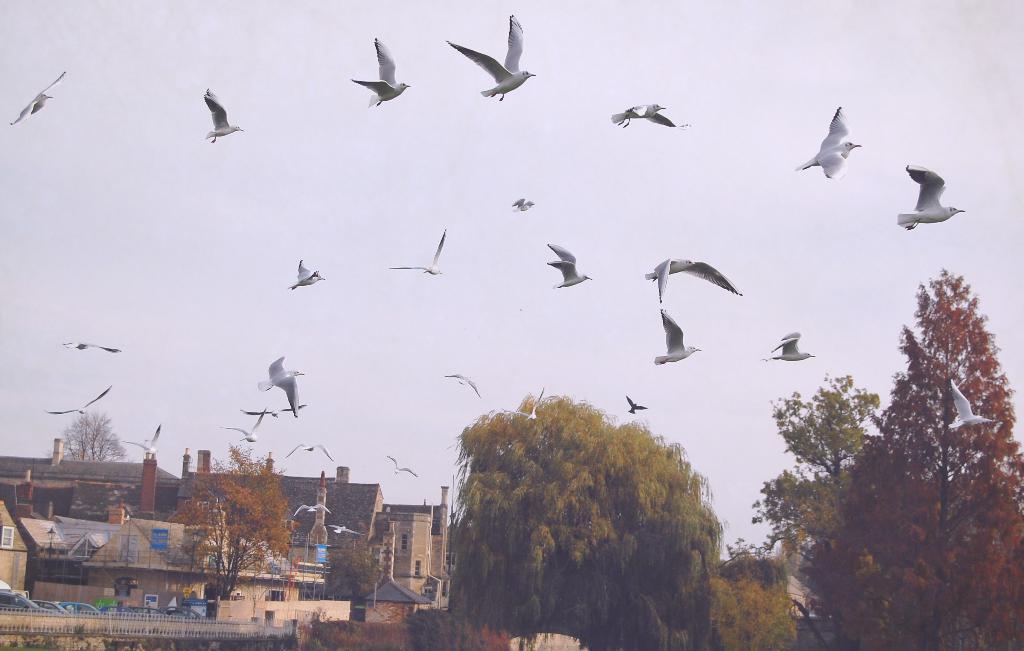Could you give a brief overview of what you see in this image? In this image I can see few buildings,fencing,vehicles,trees and few birds are flying. The sky is in white color. 